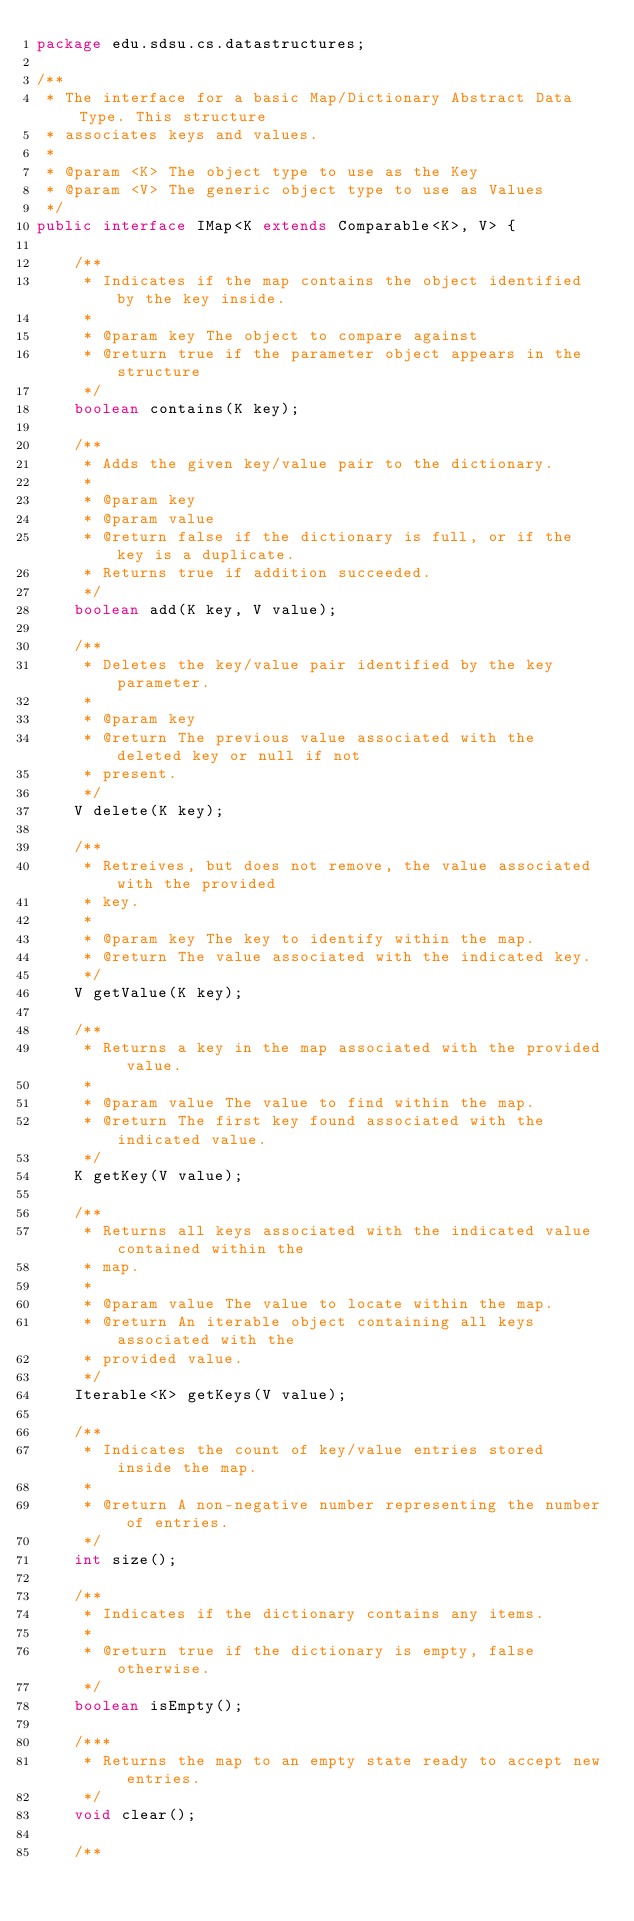<code> <loc_0><loc_0><loc_500><loc_500><_Java_>package edu.sdsu.cs.datastructures;

/**
 * The interface for a basic Map/Dictionary Abstract Data Type. This structure
 * associates keys and values.
 *
 * @param <K> The object type to use as the Key
 * @param <V> The generic object type to use as Values
 */
public interface IMap<K extends Comparable<K>, V> {

    /**
     * Indicates if the map contains the object identified by the key inside.
     *
     * @param key The object to compare against
     * @return true if the parameter object appears in the structure
     */
    boolean contains(K key);

    /**
     * Adds the given key/value pair to the dictionary.
     *
     * @param key
     * @param value
     * @return false if the dictionary is full, or if the key is a duplicate.
     * Returns true if addition succeeded.
     */
    boolean add(K key, V value);

    /**
     * Deletes the key/value pair identified by the key parameter.
     *
     * @param key
     * @return The previous value associated with the deleted key or null if not
     * present.
     */
    V delete(K key);

    /**
     * Retreives, but does not remove, the value associated with the provided
     * key.
     *
     * @param key The key to identify within the map.
     * @return The value associated with the indicated key.
     */
    V getValue(K key);

    /**
     * Returns a key in the map associated with the provided value.
     *
     * @param value The value to find within the map.
     * @return The first key found associated with the indicated value.
     */
    K getKey(V value);

    /**
     * Returns all keys associated with the indicated value contained within the
     * map.
     *
     * @param value The value to locate within the map.
     * @return An iterable object containing all keys associated with the
     * provided value.
     */
    Iterable<K> getKeys(V value);

    /**
     * Indicates the count of key/value entries stored inside the map.
     *
     * @return A non-negative number representing the number of entries.
     */
    int size();

    /**
     * Indicates if the dictionary contains any items.
     *
     * @return true if the dictionary is empty, false otherwise.
     */
    boolean isEmpty();

    /***
     * Returns the map to an empty state ready to accept new entries.
     */
    void clear();

    /**</code> 